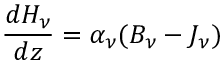<formula> <loc_0><loc_0><loc_500><loc_500>{ \frac { d H _ { \nu } } { d z } } = \alpha _ { \nu } ( B _ { \nu } - J _ { \nu } )</formula> 